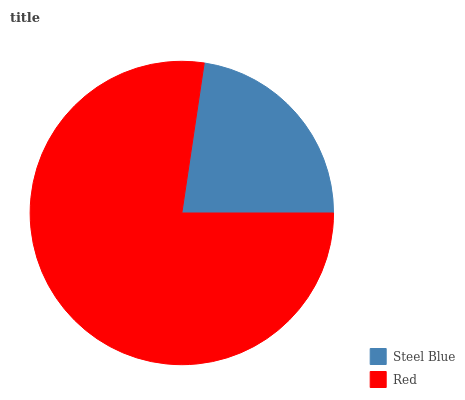Is Steel Blue the minimum?
Answer yes or no. Yes. Is Red the maximum?
Answer yes or no. Yes. Is Red the minimum?
Answer yes or no. No. Is Red greater than Steel Blue?
Answer yes or no. Yes. Is Steel Blue less than Red?
Answer yes or no. Yes. Is Steel Blue greater than Red?
Answer yes or no. No. Is Red less than Steel Blue?
Answer yes or no. No. Is Red the high median?
Answer yes or no. Yes. Is Steel Blue the low median?
Answer yes or no. Yes. Is Steel Blue the high median?
Answer yes or no. No. Is Red the low median?
Answer yes or no. No. 